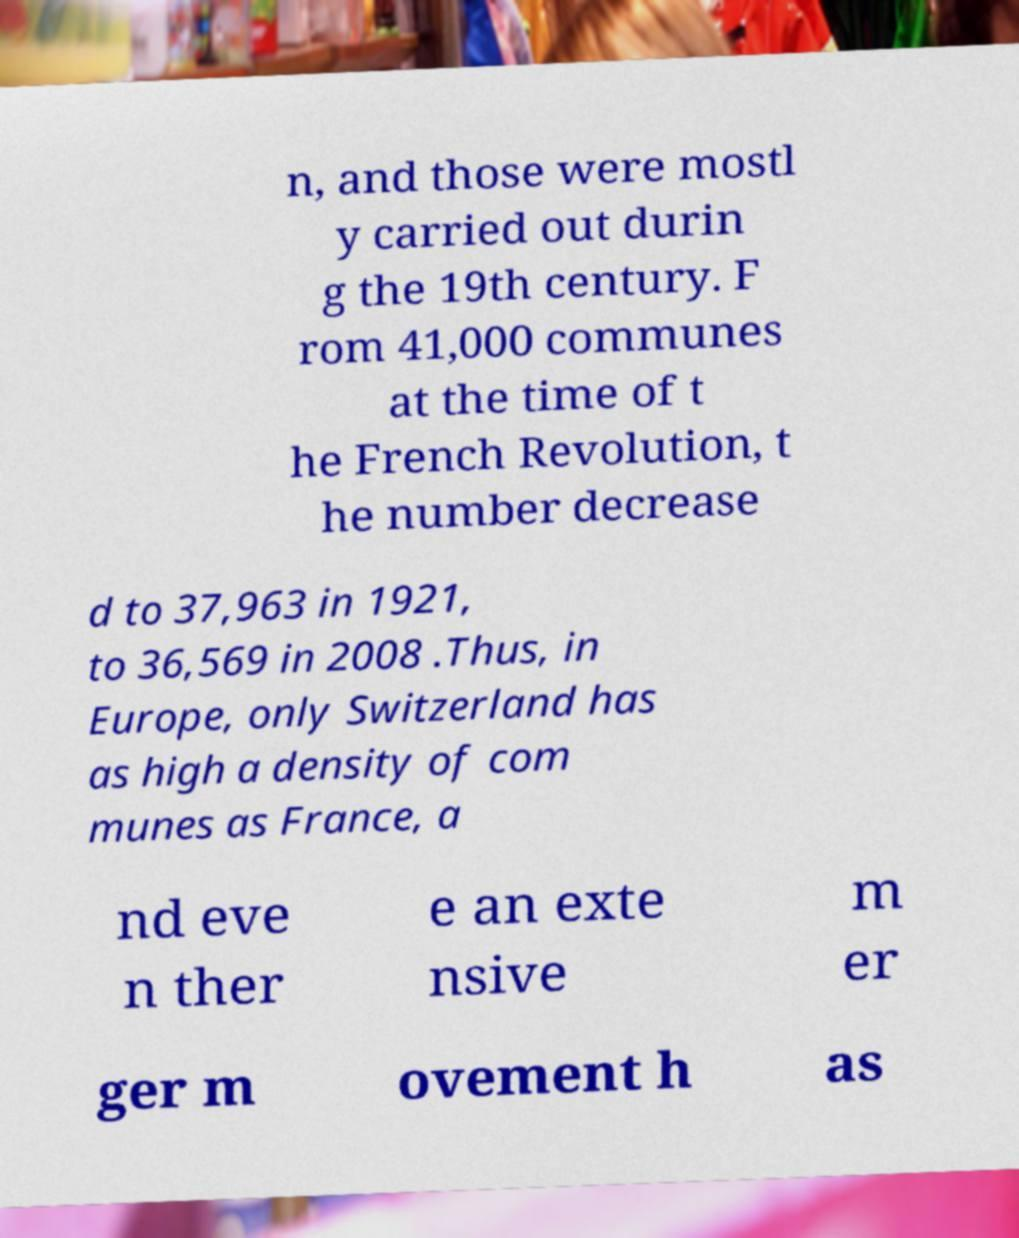Can you read and provide the text displayed in the image?This photo seems to have some interesting text. Can you extract and type it out for me? n, and those were mostl y carried out durin g the 19th century. F rom 41,000 communes at the time of t he French Revolution, t he number decrease d to 37,963 in 1921, to 36,569 in 2008 .Thus, in Europe, only Switzerland has as high a density of com munes as France, a nd eve n ther e an exte nsive m er ger m ovement h as 